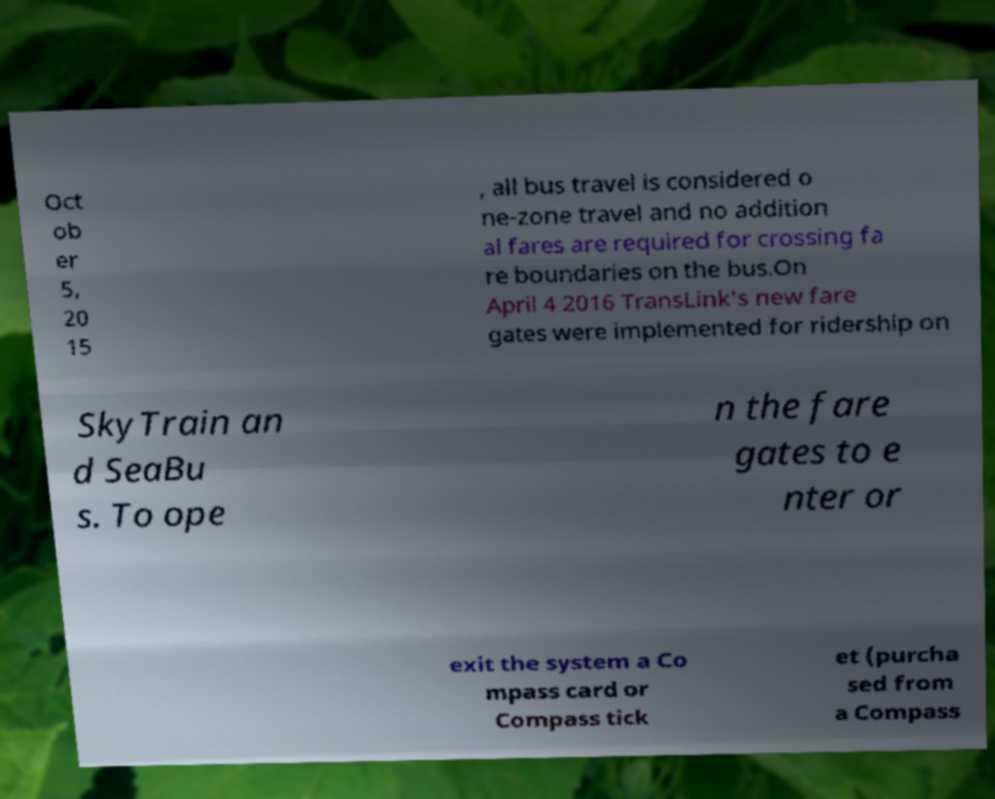Please identify and transcribe the text found in this image. Oct ob er 5, 20 15 , all bus travel is considered o ne-zone travel and no addition al fares are required for crossing fa re boundaries on the bus.On April 4 2016 TransLink's new fare gates were implemented for ridership on SkyTrain an d SeaBu s. To ope n the fare gates to e nter or exit the system a Co mpass card or Compass tick et (purcha sed from a Compass 